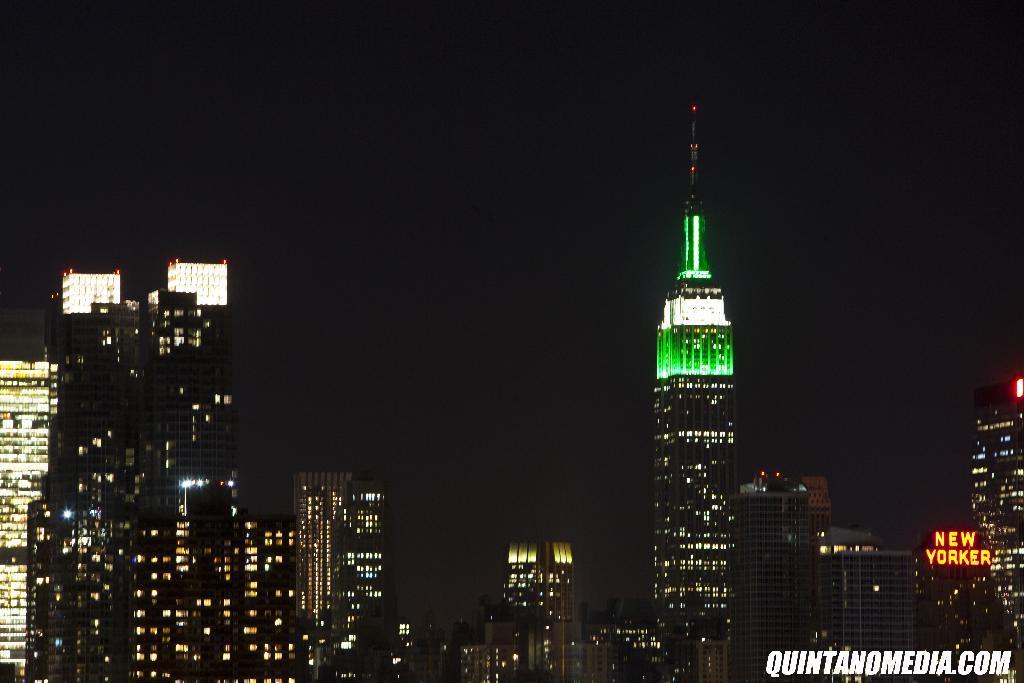In one or two sentences, can you explain what this image depicts? In this image I can see many buildings with lights. To the right I can see a name new yorker is written on one of the building. I can also see the watermark in this image. And there is a black background. 